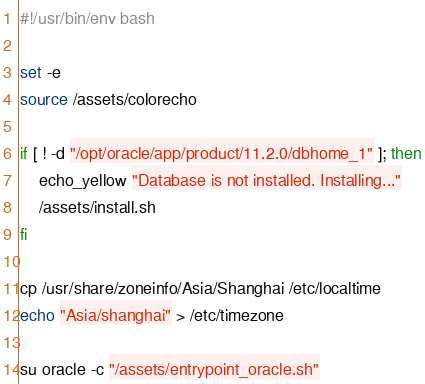<code> <loc_0><loc_0><loc_500><loc_500><_Bash_>#!/usr/bin/env bash

set -e
source /assets/colorecho

if [ ! -d "/opt/oracle/app/product/11.2.0/dbhome_1" ]; then
	echo_yellow "Database is not installed. Installing..."
	/assets/install.sh
fi

cp /usr/share/zoneinfo/Asia/Shanghai /etc/localtime
echo "Asia/shanghai" > /etc/timezone

su oracle -c "/assets/entrypoint_oracle.sh"

</code> 